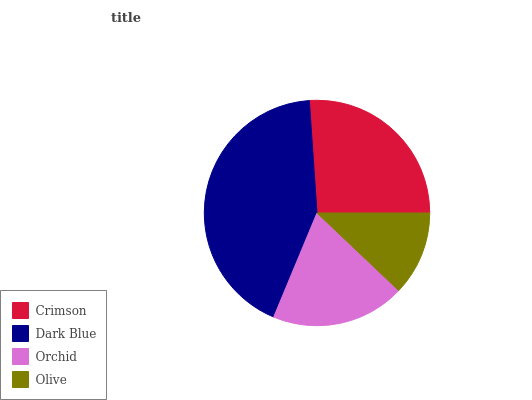Is Olive the minimum?
Answer yes or no. Yes. Is Dark Blue the maximum?
Answer yes or no. Yes. Is Orchid the minimum?
Answer yes or no. No. Is Orchid the maximum?
Answer yes or no. No. Is Dark Blue greater than Orchid?
Answer yes or no. Yes. Is Orchid less than Dark Blue?
Answer yes or no. Yes. Is Orchid greater than Dark Blue?
Answer yes or no. No. Is Dark Blue less than Orchid?
Answer yes or no. No. Is Crimson the high median?
Answer yes or no. Yes. Is Orchid the low median?
Answer yes or no. Yes. Is Dark Blue the high median?
Answer yes or no. No. Is Olive the low median?
Answer yes or no. No. 